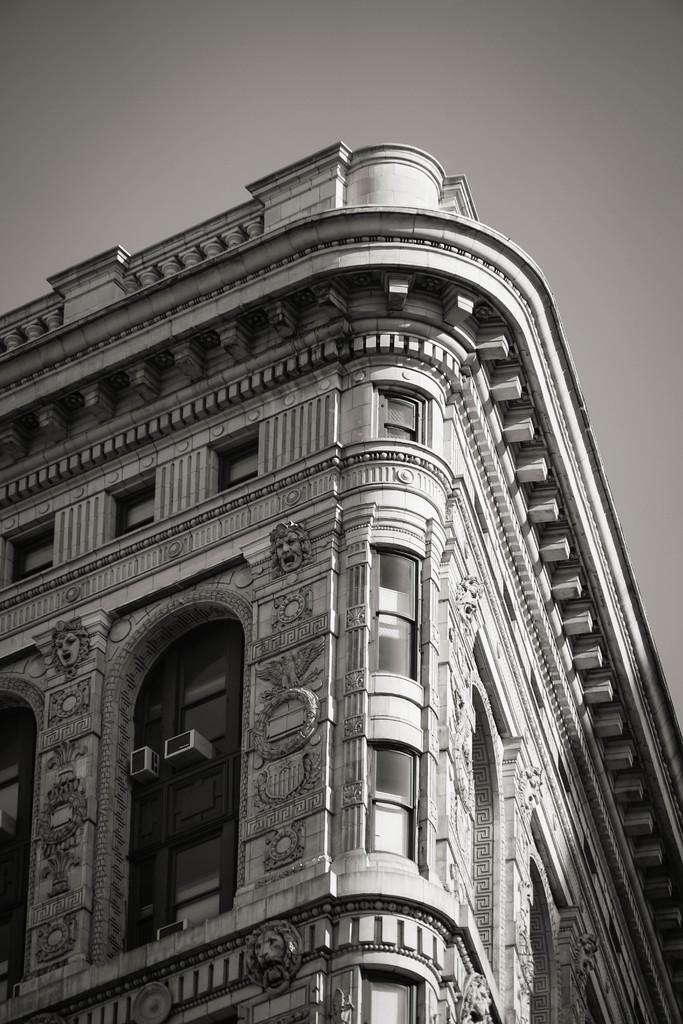What is the color scheme of the image? The image is black and white. What structure is present in the image? There is a building in the image. What features can be observed on the building? The building has windows and air conditioners. What is visible in the background of the image? The sky is visible in the image. Can you see any ghosts in the image? There are no ghosts present in the image. Is there is a train visible in the image? There is no train present in the image. 